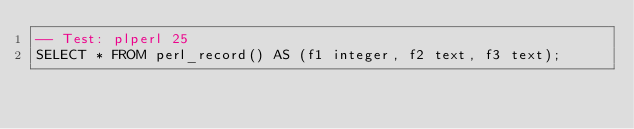<code> <loc_0><loc_0><loc_500><loc_500><_SQL_>-- Test: plperl 25
SELECT * FROM perl_record() AS (f1 integer, f2 text, f3 text);
							  

</code> 